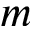Convert formula to latex. <formula><loc_0><loc_0><loc_500><loc_500>m</formula> 